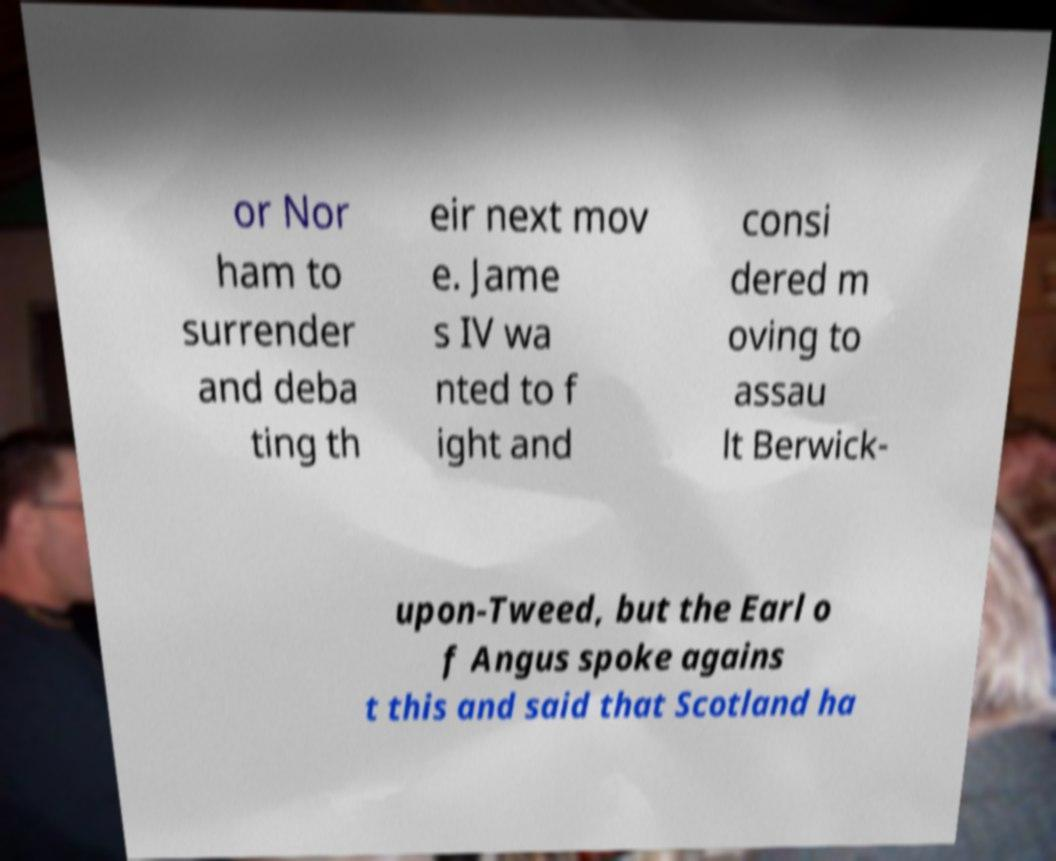There's text embedded in this image that I need extracted. Can you transcribe it verbatim? or Nor ham to surrender and deba ting th eir next mov e. Jame s IV wa nted to f ight and consi dered m oving to assau lt Berwick- upon-Tweed, but the Earl o f Angus spoke agains t this and said that Scotland ha 